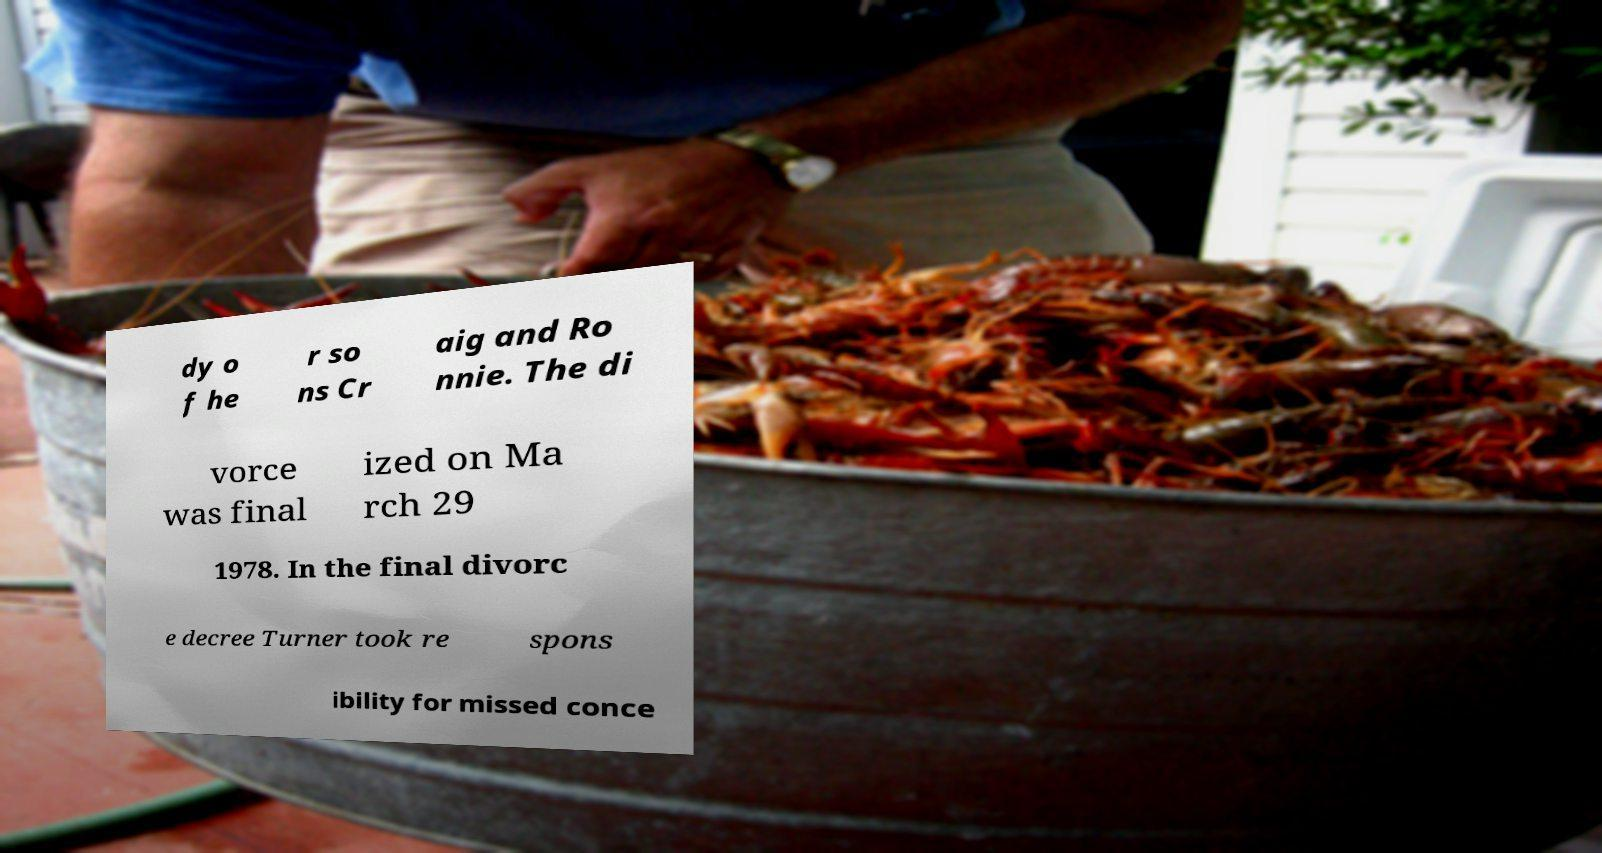Can you read and provide the text displayed in the image?This photo seems to have some interesting text. Can you extract and type it out for me? dy o f he r so ns Cr aig and Ro nnie. The di vorce was final ized on Ma rch 29 1978. In the final divorc e decree Turner took re spons ibility for missed conce 